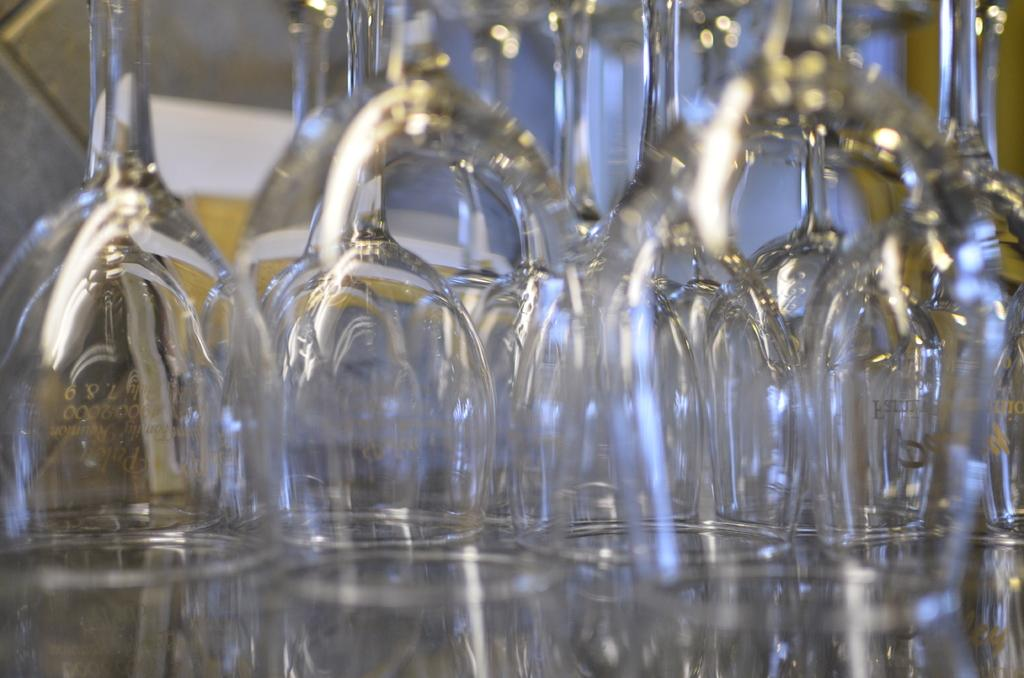What type of glasses can be seen in the image? There are wine glasses in the image. How are the wine glasses arranged? The wine glasses are arranged in the image. What type of grape is being used to fill the wine glasses in the image? There is no indication of the type of grape or any liquid in the wine glasses in the image. Can you tell me who is performing an operation on the wine glasses in the image? There is no operation or person performing an operation on the wine glasses in the image. 